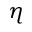Convert formula to latex. <formula><loc_0><loc_0><loc_500><loc_500>\eta</formula> 